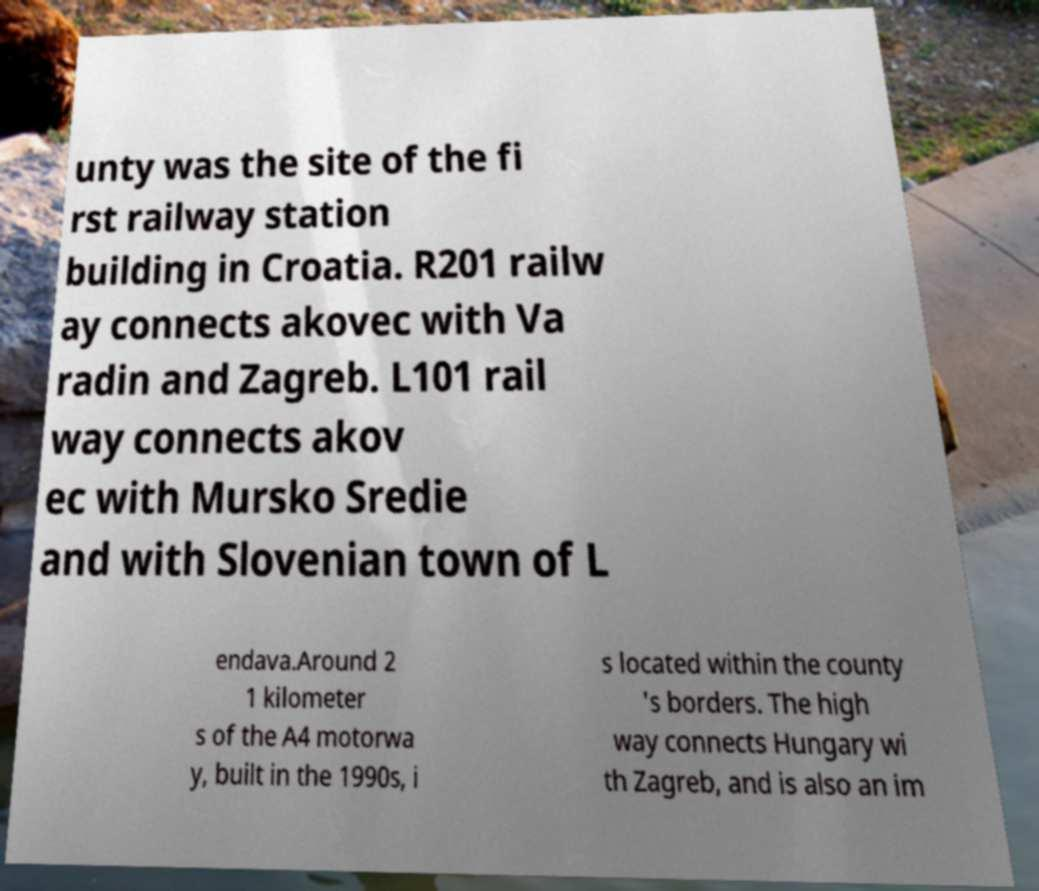Please read and relay the text visible in this image. What does it say? unty was the site of the fi rst railway station building in Croatia. R201 railw ay connects akovec with Va radin and Zagreb. L101 rail way connects akov ec with Mursko Sredie and with Slovenian town of L endava.Around 2 1 kilometer s of the A4 motorwa y, built in the 1990s, i s located within the county 's borders. The high way connects Hungary wi th Zagreb, and is also an im 